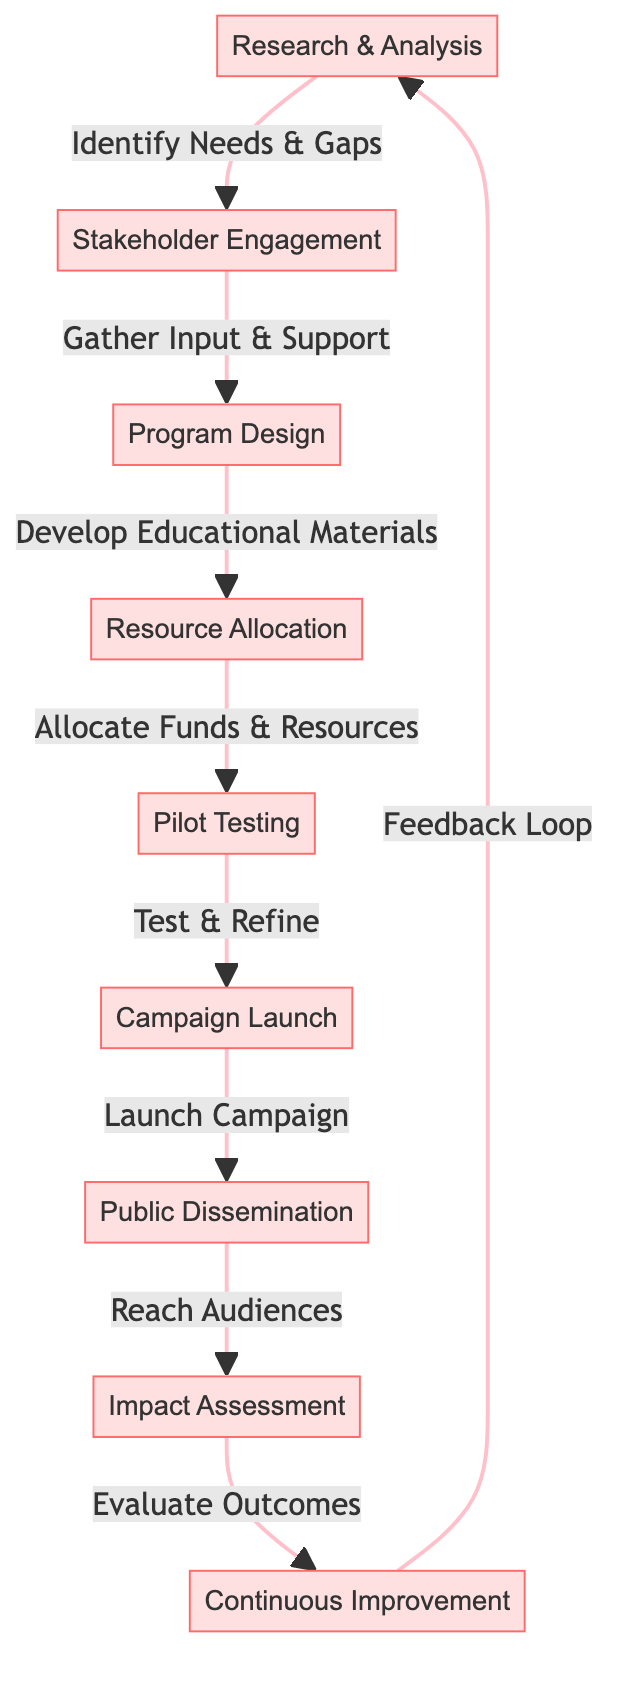What is the first step in the campaign implementation chain? The first node in the diagram is "Research & Analysis," indicating that this is the starting point for the campaign implementation process.
Answer: Research & Analysis How many nodes are present in the diagram? The diagram contains a total of nine distinct nodes, each representing a step in the campaign implementation chain.
Answer: 9 Which node follows "Pilot Testing"? The flow from "Pilot Testing" indicates that the next node is "Campaign Launch," which comes immediately after it in the sequence of steps.
Answer: Campaign Launch What does "Public Dissemination" lead to? According to the diagram, the node "Public Dissemination" flows into "Impact Assessment," signifying the next step after publicizing the campaign.
Answer: Impact Assessment Which node involves gathering input and support? The node "Stakeholder Engagement" is where input and support are gathered, as indicated by the flow leading from "Research & Analysis" to "Stakeholder Engagement."
Answer: Stakeholder Engagement What is the final step in the campaign chain? The last node in the diagram is "Continuous Improvement," which indicates ongoing efforts to enhance the campaign after evaluation.
Answer: Continuous Improvement What is the relationship between "Resource Allocation" and "Program Design"? "Resource Allocation" directly follows "Program Design," implying that resources are allocated after the program has been designed.
Answer: Resource Allocation follows Program Design Which step is essential for testing and refining the campaign? The "Pilot Testing" node is specifically dedicated to testing and refining the campaign materials before launching broadly.
Answer: Pilot Testing How does the chain cycle back to the beginning? After "Continuous Improvement," the diagram shows a feedback loop that points back to "Research & Analysis," demonstrating the iterative nature of the process.
Answer: Feedback Loop to Research & Analysis 